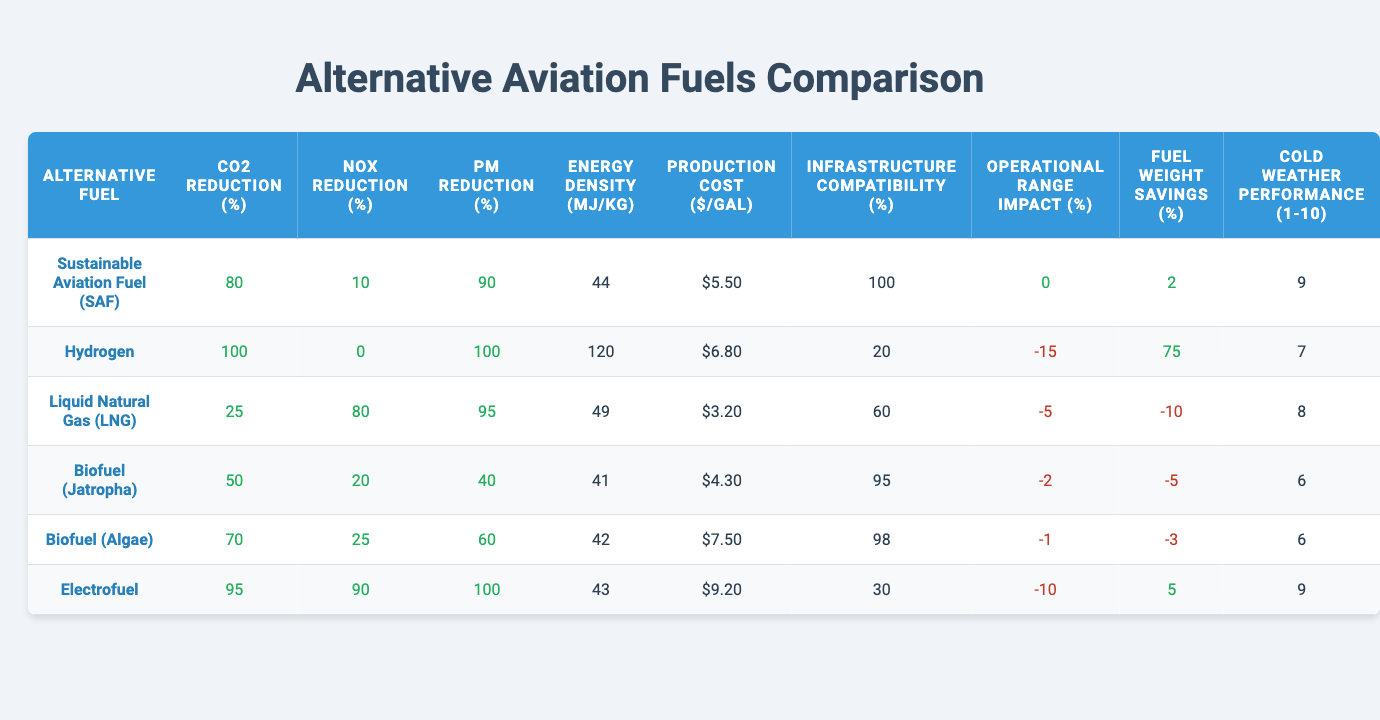What is the CO2 emissions reduction percentage for Sustainable Aviation Fuel (SAF)? The table shows that the CO2 emissions reduction for Sustainable Aviation Fuel (SAF) is listed as 80%.
Answer: 80% Which alternative fuel has the highest NOx emissions reduction? From the table, it's clear that Electrofuel has the highest NOx emissions reduction at 90%.
Answer: 90% How does the energy density of Hydrogen compare to that of Biofuel (Jatropha)? The energy density for Hydrogen is 120 MJ/kg, while for Biofuel (Jatropha) it is 41 MJ/kg. Hence, Hydrogen has a higher energy density.
Answer: Hydrogen has a higher energy density What is the average particulate matter reduction percentage across all fuels? Adding the particulate matter reductions (90 + 100 + 95 + 40 + 60 + 100) gives 485, and dividing by 6 yields an average of 80.83%.
Answer: 80.83% Which fuel type has the lowest production cost per gallon? Liquid Natural Gas (LNG) has the lowest production cost per gallon at $3.20.
Answer: $3.20 True or False: Hydrogen has a 0% reduction in CO2 emissions. The table shows that Hydrogen has a 100% reduction in CO2 emissions, so the statement is false.
Answer: False If we consider both Carbon and NOx emissions reductions, which alternative fuel is most beneficial in terms of both metrics? Sustainable Aviation Fuel (SAF) provides an 80% reduction in CO2 emissions and a 10% reduction in NOx emissions, while Biofuel (Algae) has a 70% reduction in CO2 and a 25% reduction in NOx. SAF is better overall due to its higher CO2 reduction.
Answer: Sustainable Aviation Fuel (SAF) What is the operational range impact of using Hydrogen as an alternative fuel? The operational range impact value for Hydrogen is -15%, which means it negatively impacts operational range.
Answer: -15% Which fuel has the best cold weather performance rating? Both Sustainable Aviation Fuel (SAF) and Electrofuel have the highest cold weather performance rating of 9 out of 10.
Answer: 9 What is the total reduction percentage for Particulate Matter (PM) from Liquid Natural Gas (LNG)? The table states that Liquid Natural Gas (LNG) offers a 95% reduction in Particulate Matter.
Answer: 95% 